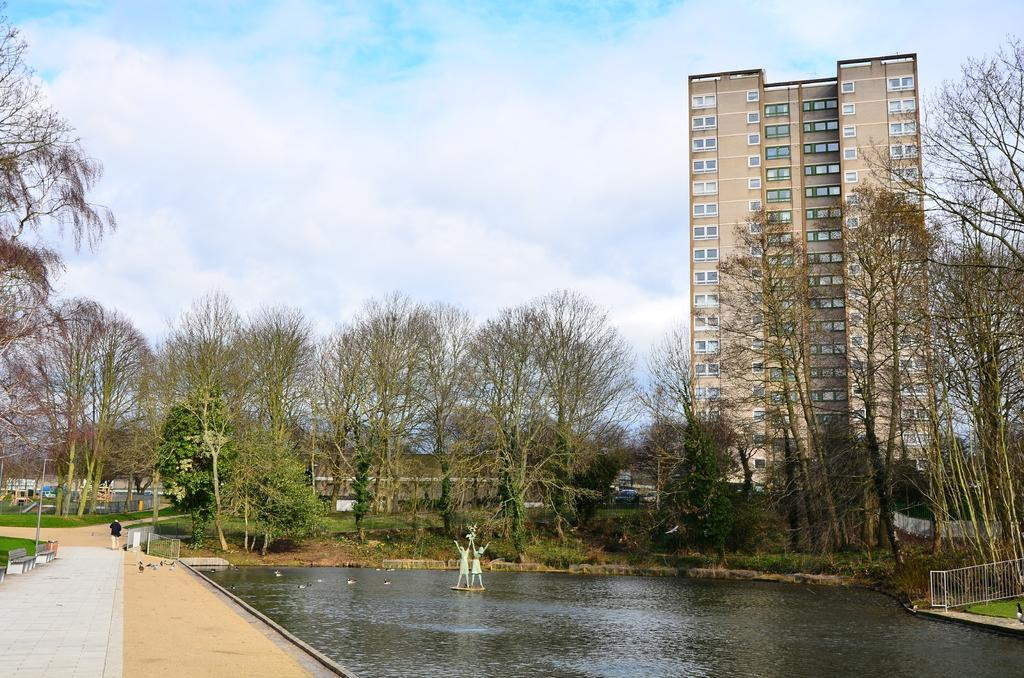What is present in the image? There is a person, water, statues, a railing, grass, benches, plants, trees, a building, and sky visible in the image. Can you describe the setting of the image? The image features a person near water, with statues, a railing, grass, benches, plants, and trees surrounding the area. There is a building in the background, and sky is visible as well. What type of structures are present in the image? There are statues, a railing, benches, and a building visible in the image. What type of natural elements are present in the image? Grass, plants, trees, water, and sky are present in the image. How many windows are visible in the image? There are no windows visible in the image. What type of adjustment can be seen being made to the shoe in the image? There is no shoe present in the image, and therefore no adjustment can be observed. 